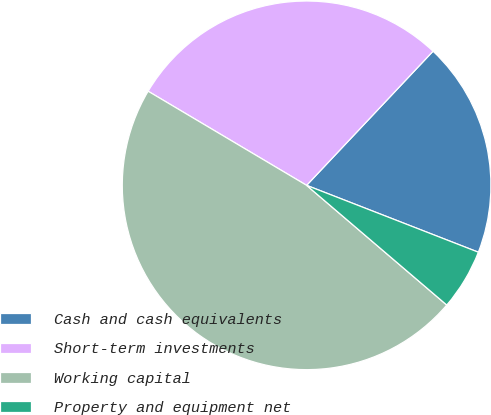Convert chart. <chart><loc_0><loc_0><loc_500><loc_500><pie_chart><fcel>Cash and cash equivalents<fcel>Short-term investments<fcel>Working capital<fcel>Property and equipment net<nl><fcel>18.88%<fcel>28.5%<fcel>47.28%<fcel>5.34%<nl></chart> 